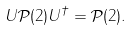Convert formula to latex. <formula><loc_0><loc_0><loc_500><loc_500>U \mathcal { P } ( 2 ) U ^ { \dagger } = \mathcal { P } ( 2 ) .</formula> 